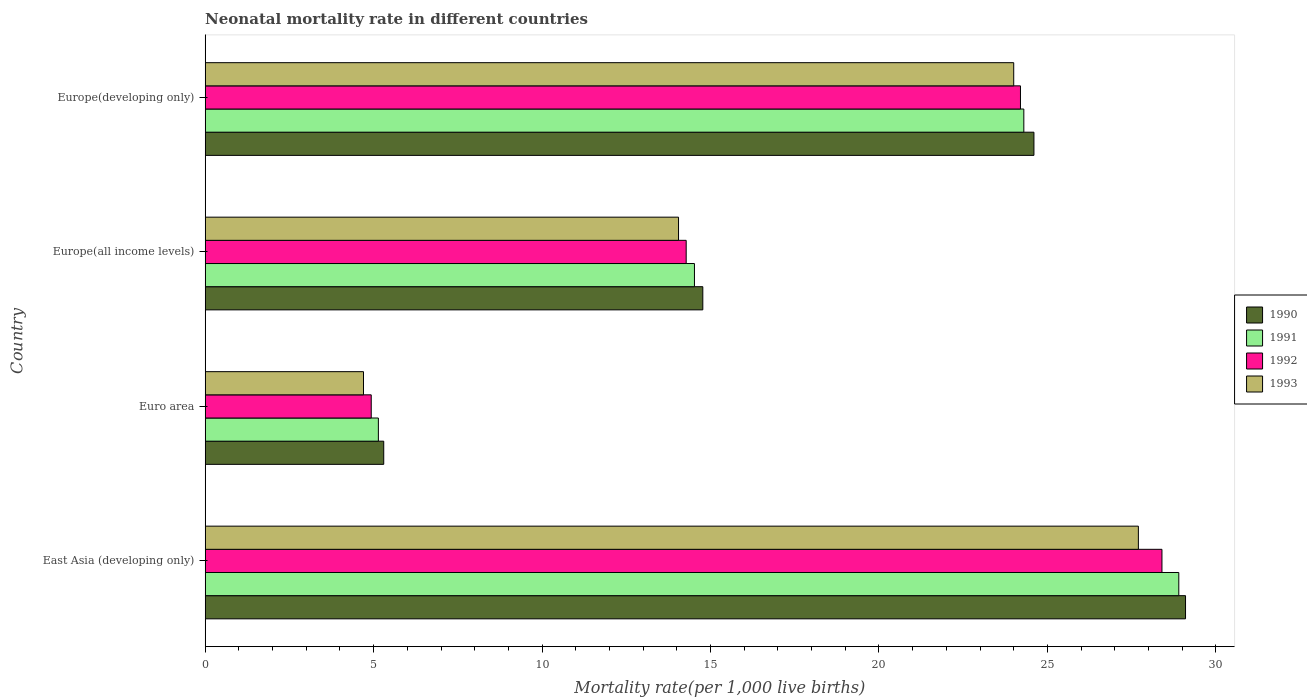How many groups of bars are there?
Your response must be concise. 4. Are the number of bars per tick equal to the number of legend labels?
Your answer should be compact. Yes. Are the number of bars on each tick of the Y-axis equal?
Ensure brevity in your answer.  Yes. How many bars are there on the 1st tick from the top?
Provide a succinct answer. 4. What is the label of the 2nd group of bars from the top?
Offer a terse response. Europe(all income levels). In how many cases, is the number of bars for a given country not equal to the number of legend labels?
Your response must be concise. 0. What is the neonatal mortality rate in 1992 in Euro area?
Your answer should be very brief. 4.93. Across all countries, what is the maximum neonatal mortality rate in 1990?
Provide a short and direct response. 29.1. Across all countries, what is the minimum neonatal mortality rate in 1990?
Offer a very short reply. 5.3. In which country was the neonatal mortality rate in 1990 maximum?
Provide a succinct answer. East Asia (developing only). What is the total neonatal mortality rate in 1992 in the graph?
Ensure brevity in your answer.  71.81. What is the difference between the neonatal mortality rate in 1993 in East Asia (developing only) and that in Europe(all income levels)?
Your response must be concise. 13.65. What is the difference between the neonatal mortality rate in 1990 in Euro area and the neonatal mortality rate in 1992 in East Asia (developing only)?
Provide a short and direct response. -23.1. What is the average neonatal mortality rate in 1993 per country?
Provide a succinct answer. 17.61. What is the difference between the neonatal mortality rate in 1990 and neonatal mortality rate in 1992 in Euro area?
Make the answer very short. 0.37. In how many countries, is the neonatal mortality rate in 1993 greater than 2 ?
Your answer should be very brief. 4. What is the ratio of the neonatal mortality rate in 1990 in Europe(all income levels) to that in Europe(developing only)?
Offer a very short reply. 0.6. Is the difference between the neonatal mortality rate in 1990 in East Asia (developing only) and Europe(all income levels) greater than the difference between the neonatal mortality rate in 1992 in East Asia (developing only) and Europe(all income levels)?
Provide a short and direct response. Yes. What is the difference between the highest and the second highest neonatal mortality rate in 1990?
Your response must be concise. 4.5. What is the difference between the highest and the lowest neonatal mortality rate in 1993?
Give a very brief answer. 23. Is the sum of the neonatal mortality rate in 1990 in East Asia (developing only) and Europe(all income levels) greater than the maximum neonatal mortality rate in 1992 across all countries?
Offer a very short reply. Yes. Is it the case that in every country, the sum of the neonatal mortality rate in 1993 and neonatal mortality rate in 1992 is greater than the sum of neonatal mortality rate in 1990 and neonatal mortality rate in 1991?
Ensure brevity in your answer.  No. What does the 2nd bar from the top in East Asia (developing only) represents?
Make the answer very short. 1992. What does the 2nd bar from the bottom in Europe(all income levels) represents?
Give a very brief answer. 1991. Is it the case that in every country, the sum of the neonatal mortality rate in 1991 and neonatal mortality rate in 1993 is greater than the neonatal mortality rate in 1992?
Your answer should be compact. Yes. How many countries are there in the graph?
Ensure brevity in your answer.  4. What is the difference between two consecutive major ticks on the X-axis?
Offer a terse response. 5. Does the graph contain any zero values?
Ensure brevity in your answer.  No. Where does the legend appear in the graph?
Offer a very short reply. Center right. How many legend labels are there?
Your answer should be compact. 4. How are the legend labels stacked?
Offer a very short reply. Vertical. What is the title of the graph?
Offer a terse response. Neonatal mortality rate in different countries. What is the label or title of the X-axis?
Provide a succinct answer. Mortality rate(per 1,0 live births). What is the label or title of the Y-axis?
Ensure brevity in your answer.  Country. What is the Mortality rate(per 1,000 live births) of 1990 in East Asia (developing only)?
Provide a succinct answer. 29.1. What is the Mortality rate(per 1,000 live births) in 1991 in East Asia (developing only)?
Provide a short and direct response. 28.9. What is the Mortality rate(per 1,000 live births) in 1992 in East Asia (developing only)?
Ensure brevity in your answer.  28.4. What is the Mortality rate(per 1,000 live births) of 1993 in East Asia (developing only)?
Your response must be concise. 27.7. What is the Mortality rate(per 1,000 live births) of 1990 in Euro area?
Make the answer very short. 5.3. What is the Mortality rate(per 1,000 live births) of 1991 in Euro area?
Your answer should be very brief. 5.14. What is the Mortality rate(per 1,000 live births) of 1992 in Euro area?
Keep it short and to the point. 4.93. What is the Mortality rate(per 1,000 live births) of 1993 in Euro area?
Make the answer very short. 4.7. What is the Mortality rate(per 1,000 live births) in 1990 in Europe(all income levels)?
Give a very brief answer. 14.77. What is the Mortality rate(per 1,000 live births) of 1991 in Europe(all income levels)?
Provide a short and direct response. 14.52. What is the Mortality rate(per 1,000 live births) of 1992 in Europe(all income levels)?
Provide a succinct answer. 14.28. What is the Mortality rate(per 1,000 live births) of 1993 in Europe(all income levels)?
Give a very brief answer. 14.05. What is the Mortality rate(per 1,000 live births) of 1990 in Europe(developing only)?
Ensure brevity in your answer.  24.6. What is the Mortality rate(per 1,000 live births) of 1991 in Europe(developing only)?
Offer a terse response. 24.3. What is the Mortality rate(per 1,000 live births) in 1992 in Europe(developing only)?
Provide a short and direct response. 24.2. Across all countries, what is the maximum Mortality rate(per 1,000 live births) of 1990?
Your answer should be very brief. 29.1. Across all countries, what is the maximum Mortality rate(per 1,000 live births) of 1991?
Keep it short and to the point. 28.9. Across all countries, what is the maximum Mortality rate(per 1,000 live births) of 1992?
Your answer should be very brief. 28.4. Across all countries, what is the maximum Mortality rate(per 1,000 live births) in 1993?
Offer a very short reply. 27.7. Across all countries, what is the minimum Mortality rate(per 1,000 live births) of 1990?
Keep it short and to the point. 5.3. Across all countries, what is the minimum Mortality rate(per 1,000 live births) of 1991?
Ensure brevity in your answer.  5.14. Across all countries, what is the minimum Mortality rate(per 1,000 live births) in 1992?
Provide a succinct answer. 4.93. Across all countries, what is the minimum Mortality rate(per 1,000 live births) in 1993?
Your answer should be very brief. 4.7. What is the total Mortality rate(per 1,000 live births) in 1990 in the graph?
Keep it short and to the point. 73.77. What is the total Mortality rate(per 1,000 live births) of 1991 in the graph?
Provide a succinct answer. 72.86. What is the total Mortality rate(per 1,000 live births) in 1992 in the graph?
Your response must be concise. 71.81. What is the total Mortality rate(per 1,000 live births) in 1993 in the graph?
Your answer should be very brief. 70.45. What is the difference between the Mortality rate(per 1,000 live births) in 1990 in East Asia (developing only) and that in Euro area?
Provide a succinct answer. 23.8. What is the difference between the Mortality rate(per 1,000 live births) in 1991 in East Asia (developing only) and that in Euro area?
Make the answer very short. 23.76. What is the difference between the Mortality rate(per 1,000 live births) in 1992 in East Asia (developing only) and that in Euro area?
Keep it short and to the point. 23.47. What is the difference between the Mortality rate(per 1,000 live births) of 1993 in East Asia (developing only) and that in Euro area?
Your answer should be compact. 23. What is the difference between the Mortality rate(per 1,000 live births) of 1990 in East Asia (developing only) and that in Europe(all income levels)?
Offer a terse response. 14.33. What is the difference between the Mortality rate(per 1,000 live births) of 1991 in East Asia (developing only) and that in Europe(all income levels)?
Your answer should be compact. 14.38. What is the difference between the Mortality rate(per 1,000 live births) in 1992 in East Asia (developing only) and that in Europe(all income levels)?
Your answer should be compact. 14.12. What is the difference between the Mortality rate(per 1,000 live births) of 1993 in East Asia (developing only) and that in Europe(all income levels)?
Your response must be concise. 13.65. What is the difference between the Mortality rate(per 1,000 live births) in 1992 in East Asia (developing only) and that in Europe(developing only)?
Your response must be concise. 4.2. What is the difference between the Mortality rate(per 1,000 live births) in 1990 in Euro area and that in Europe(all income levels)?
Your response must be concise. -9.47. What is the difference between the Mortality rate(per 1,000 live births) of 1991 in Euro area and that in Europe(all income levels)?
Give a very brief answer. -9.38. What is the difference between the Mortality rate(per 1,000 live births) in 1992 in Euro area and that in Europe(all income levels)?
Ensure brevity in your answer.  -9.35. What is the difference between the Mortality rate(per 1,000 live births) of 1993 in Euro area and that in Europe(all income levels)?
Your answer should be very brief. -9.35. What is the difference between the Mortality rate(per 1,000 live births) in 1990 in Euro area and that in Europe(developing only)?
Your response must be concise. -19.3. What is the difference between the Mortality rate(per 1,000 live births) in 1991 in Euro area and that in Europe(developing only)?
Provide a short and direct response. -19.16. What is the difference between the Mortality rate(per 1,000 live births) of 1992 in Euro area and that in Europe(developing only)?
Make the answer very short. -19.27. What is the difference between the Mortality rate(per 1,000 live births) of 1993 in Euro area and that in Europe(developing only)?
Your answer should be very brief. -19.3. What is the difference between the Mortality rate(per 1,000 live births) in 1990 in Europe(all income levels) and that in Europe(developing only)?
Your response must be concise. -9.83. What is the difference between the Mortality rate(per 1,000 live births) in 1991 in Europe(all income levels) and that in Europe(developing only)?
Keep it short and to the point. -9.78. What is the difference between the Mortality rate(per 1,000 live births) in 1992 in Europe(all income levels) and that in Europe(developing only)?
Make the answer very short. -9.92. What is the difference between the Mortality rate(per 1,000 live births) in 1993 in Europe(all income levels) and that in Europe(developing only)?
Provide a succinct answer. -9.95. What is the difference between the Mortality rate(per 1,000 live births) of 1990 in East Asia (developing only) and the Mortality rate(per 1,000 live births) of 1991 in Euro area?
Keep it short and to the point. 23.96. What is the difference between the Mortality rate(per 1,000 live births) of 1990 in East Asia (developing only) and the Mortality rate(per 1,000 live births) of 1992 in Euro area?
Offer a very short reply. 24.17. What is the difference between the Mortality rate(per 1,000 live births) of 1990 in East Asia (developing only) and the Mortality rate(per 1,000 live births) of 1993 in Euro area?
Offer a terse response. 24.4. What is the difference between the Mortality rate(per 1,000 live births) of 1991 in East Asia (developing only) and the Mortality rate(per 1,000 live births) of 1992 in Euro area?
Your response must be concise. 23.97. What is the difference between the Mortality rate(per 1,000 live births) in 1991 in East Asia (developing only) and the Mortality rate(per 1,000 live births) in 1993 in Euro area?
Your answer should be very brief. 24.2. What is the difference between the Mortality rate(per 1,000 live births) in 1992 in East Asia (developing only) and the Mortality rate(per 1,000 live births) in 1993 in Euro area?
Your response must be concise. 23.7. What is the difference between the Mortality rate(per 1,000 live births) in 1990 in East Asia (developing only) and the Mortality rate(per 1,000 live births) in 1991 in Europe(all income levels)?
Your answer should be very brief. 14.58. What is the difference between the Mortality rate(per 1,000 live births) of 1990 in East Asia (developing only) and the Mortality rate(per 1,000 live births) of 1992 in Europe(all income levels)?
Give a very brief answer. 14.82. What is the difference between the Mortality rate(per 1,000 live births) of 1990 in East Asia (developing only) and the Mortality rate(per 1,000 live births) of 1993 in Europe(all income levels)?
Your response must be concise. 15.05. What is the difference between the Mortality rate(per 1,000 live births) in 1991 in East Asia (developing only) and the Mortality rate(per 1,000 live births) in 1992 in Europe(all income levels)?
Your answer should be very brief. 14.62. What is the difference between the Mortality rate(per 1,000 live births) in 1991 in East Asia (developing only) and the Mortality rate(per 1,000 live births) in 1993 in Europe(all income levels)?
Provide a succinct answer. 14.85. What is the difference between the Mortality rate(per 1,000 live births) of 1992 in East Asia (developing only) and the Mortality rate(per 1,000 live births) of 1993 in Europe(all income levels)?
Give a very brief answer. 14.35. What is the difference between the Mortality rate(per 1,000 live births) of 1990 in East Asia (developing only) and the Mortality rate(per 1,000 live births) of 1991 in Europe(developing only)?
Make the answer very short. 4.8. What is the difference between the Mortality rate(per 1,000 live births) of 1990 in East Asia (developing only) and the Mortality rate(per 1,000 live births) of 1993 in Europe(developing only)?
Provide a short and direct response. 5.1. What is the difference between the Mortality rate(per 1,000 live births) of 1991 in East Asia (developing only) and the Mortality rate(per 1,000 live births) of 1993 in Europe(developing only)?
Provide a succinct answer. 4.9. What is the difference between the Mortality rate(per 1,000 live births) in 1990 in Euro area and the Mortality rate(per 1,000 live births) in 1991 in Europe(all income levels)?
Ensure brevity in your answer.  -9.22. What is the difference between the Mortality rate(per 1,000 live births) in 1990 in Euro area and the Mortality rate(per 1,000 live births) in 1992 in Europe(all income levels)?
Provide a short and direct response. -8.98. What is the difference between the Mortality rate(per 1,000 live births) of 1990 in Euro area and the Mortality rate(per 1,000 live births) of 1993 in Europe(all income levels)?
Provide a short and direct response. -8.75. What is the difference between the Mortality rate(per 1,000 live births) in 1991 in Euro area and the Mortality rate(per 1,000 live births) in 1992 in Europe(all income levels)?
Give a very brief answer. -9.14. What is the difference between the Mortality rate(per 1,000 live births) of 1991 in Euro area and the Mortality rate(per 1,000 live births) of 1993 in Europe(all income levels)?
Give a very brief answer. -8.91. What is the difference between the Mortality rate(per 1,000 live births) in 1992 in Euro area and the Mortality rate(per 1,000 live births) in 1993 in Europe(all income levels)?
Offer a terse response. -9.12. What is the difference between the Mortality rate(per 1,000 live births) in 1990 in Euro area and the Mortality rate(per 1,000 live births) in 1991 in Europe(developing only)?
Make the answer very short. -19. What is the difference between the Mortality rate(per 1,000 live births) in 1990 in Euro area and the Mortality rate(per 1,000 live births) in 1992 in Europe(developing only)?
Provide a short and direct response. -18.9. What is the difference between the Mortality rate(per 1,000 live births) of 1990 in Euro area and the Mortality rate(per 1,000 live births) of 1993 in Europe(developing only)?
Provide a succinct answer. -18.7. What is the difference between the Mortality rate(per 1,000 live births) in 1991 in Euro area and the Mortality rate(per 1,000 live births) in 1992 in Europe(developing only)?
Offer a very short reply. -19.06. What is the difference between the Mortality rate(per 1,000 live births) in 1991 in Euro area and the Mortality rate(per 1,000 live births) in 1993 in Europe(developing only)?
Offer a very short reply. -18.86. What is the difference between the Mortality rate(per 1,000 live births) of 1992 in Euro area and the Mortality rate(per 1,000 live births) of 1993 in Europe(developing only)?
Your answer should be compact. -19.07. What is the difference between the Mortality rate(per 1,000 live births) of 1990 in Europe(all income levels) and the Mortality rate(per 1,000 live births) of 1991 in Europe(developing only)?
Your answer should be very brief. -9.53. What is the difference between the Mortality rate(per 1,000 live births) of 1990 in Europe(all income levels) and the Mortality rate(per 1,000 live births) of 1992 in Europe(developing only)?
Your answer should be compact. -9.43. What is the difference between the Mortality rate(per 1,000 live births) in 1990 in Europe(all income levels) and the Mortality rate(per 1,000 live births) in 1993 in Europe(developing only)?
Provide a succinct answer. -9.23. What is the difference between the Mortality rate(per 1,000 live births) in 1991 in Europe(all income levels) and the Mortality rate(per 1,000 live births) in 1992 in Europe(developing only)?
Your answer should be compact. -9.68. What is the difference between the Mortality rate(per 1,000 live births) in 1991 in Europe(all income levels) and the Mortality rate(per 1,000 live births) in 1993 in Europe(developing only)?
Your answer should be compact. -9.48. What is the difference between the Mortality rate(per 1,000 live births) of 1992 in Europe(all income levels) and the Mortality rate(per 1,000 live births) of 1993 in Europe(developing only)?
Give a very brief answer. -9.72. What is the average Mortality rate(per 1,000 live births) in 1990 per country?
Give a very brief answer. 18.44. What is the average Mortality rate(per 1,000 live births) of 1991 per country?
Your answer should be very brief. 18.22. What is the average Mortality rate(per 1,000 live births) in 1992 per country?
Ensure brevity in your answer.  17.95. What is the average Mortality rate(per 1,000 live births) of 1993 per country?
Provide a short and direct response. 17.61. What is the difference between the Mortality rate(per 1,000 live births) in 1990 and Mortality rate(per 1,000 live births) in 1991 in East Asia (developing only)?
Provide a short and direct response. 0.2. What is the difference between the Mortality rate(per 1,000 live births) in 1990 and Mortality rate(per 1,000 live births) in 1992 in East Asia (developing only)?
Your response must be concise. 0.7. What is the difference between the Mortality rate(per 1,000 live births) of 1990 and Mortality rate(per 1,000 live births) of 1993 in East Asia (developing only)?
Provide a succinct answer. 1.4. What is the difference between the Mortality rate(per 1,000 live births) of 1990 and Mortality rate(per 1,000 live births) of 1991 in Euro area?
Provide a succinct answer. 0.16. What is the difference between the Mortality rate(per 1,000 live births) of 1990 and Mortality rate(per 1,000 live births) of 1992 in Euro area?
Your response must be concise. 0.37. What is the difference between the Mortality rate(per 1,000 live births) of 1990 and Mortality rate(per 1,000 live births) of 1993 in Euro area?
Keep it short and to the point. 0.6. What is the difference between the Mortality rate(per 1,000 live births) of 1991 and Mortality rate(per 1,000 live births) of 1992 in Euro area?
Give a very brief answer. 0.21. What is the difference between the Mortality rate(per 1,000 live births) of 1991 and Mortality rate(per 1,000 live births) of 1993 in Euro area?
Give a very brief answer. 0.44. What is the difference between the Mortality rate(per 1,000 live births) of 1992 and Mortality rate(per 1,000 live births) of 1993 in Euro area?
Give a very brief answer. 0.23. What is the difference between the Mortality rate(per 1,000 live births) in 1990 and Mortality rate(per 1,000 live births) in 1991 in Europe(all income levels)?
Offer a terse response. 0.25. What is the difference between the Mortality rate(per 1,000 live births) of 1990 and Mortality rate(per 1,000 live births) of 1992 in Europe(all income levels)?
Provide a short and direct response. 0.49. What is the difference between the Mortality rate(per 1,000 live births) of 1990 and Mortality rate(per 1,000 live births) of 1993 in Europe(all income levels)?
Provide a succinct answer. 0.72. What is the difference between the Mortality rate(per 1,000 live births) in 1991 and Mortality rate(per 1,000 live births) in 1992 in Europe(all income levels)?
Offer a very short reply. 0.25. What is the difference between the Mortality rate(per 1,000 live births) in 1991 and Mortality rate(per 1,000 live births) in 1993 in Europe(all income levels)?
Provide a short and direct response. 0.47. What is the difference between the Mortality rate(per 1,000 live births) in 1992 and Mortality rate(per 1,000 live births) in 1993 in Europe(all income levels)?
Your answer should be compact. 0.23. What is the difference between the Mortality rate(per 1,000 live births) in 1990 and Mortality rate(per 1,000 live births) in 1991 in Europe(developing only)?
Keep it short and to the point. 0.3. What is the difference between the Mortality rate(per 1,000 live births) of 1990 and Mortality rate(per 1,000 live births) of 1993 in Europe(developing only)?
Provide a short and direct response. 0.6. What is the difference between the Mortality rate(per 1,000 live births) in 1992 and Mortality rate(per 1,000 live births) in 1993 in Europe(developing only)?
Keep it short and to the point. 0.2. What is the ratio of the Mortality rate(per 1,000 live births) in 1990 in East Asia (developing only) to that in Euro area?
Your response must be concise. 5.49. What is the ratio of the Mortality rate(per 1,000 live births) of 1991 in East Asia (developing only) to that in Euro area?
Make the answer very short. 5.62. What is the ratio of the Mortality rate(per 1,000 live births) of 1992 in East Asia (developing only) to that in Euro area?
Keep it short and to the point. 5.76. What is the ratio of the Mortality rate(per 1,000 live births) of 1993 in East Asia (developing only) to that in Euro area?
Ensure brevity in your answer.  5.89. What is the ratio of the Mortality rate(per 1,000 live births) of 1990 in East Asia (developing only) to that in Europe(all income levels)?
Offer a terse response. 1.97. What is the ratio of the Mortality rate(per 1,000 live births) of 1991 in East Asia (developing only) to that in Europe(all income levels)?
Ensure brevity in your answer.  1.99. What is the ratio of the Mortality rate(per 1,000 live births) of 1992 in East Asia (developing only) to that in Europe(all income levels)?
Your response must be concise. 1.99. What is the ratio of the Mortality rate(per 1,000 live births) of 1993 in East Asia (developing only) to that in Europe(all income levels)?
Ensure brevity in your answer.  1.97. What is the ratio of the Mortality rate(per 1,000 live births) of 1990 in East Asia (developing only) to that in Europe(developing only)?
Your answer should be compact. 1.18. What is the ratio of the Mortality rate(per 1,000 live births) in 1991 in East Asia (developing only) to that in Europe(developing only)?
Give a very brief answer. 1.19. What is the ratio of the Mortality rate(per 1,000 live births) in 1992 in East Asia (developing only) to that in Europe(developing only)?
Your response must be concise. 1.17. What is the ratio of the Mortality rate(per 1,000 live births) in 1993 in East Asia (developing only) to that in Europe(developing only)?
Ensure brevity in your answer.  1.15. What is the ratio of the Mortality rate(per 1,000 live births) in 1990 in Euro area to that in Europe(all income levels)?
Make the answer very short. 0.36. What is the ratio of the Mortality rate(per 1,000 live births) of 1991 in Euro area to that in Europe(all income levels)?
Give a very brief answer. 0.35. What is the ratio of the Mortality rate(per 1,000 live births) in 1992 in Euro area to that in Europe(all income levels)?
Ensure brevity in your answer.  0.35. What is the ratio of the Mortality rate(per 1,000 live births) in 1993 in Euro area to that in Europe(all income levels)?
Offer a terse response. 0.33. What is the ratio of the Mortality rate(per 1,000 live births) in 1990 in Euro area to that in Europe(developing only)?
Your answer should be compact. 0.22. What is the ratio of the Mortality rate(per 1,000 live births) in 1991 in Euro area to that in Europe(developing only)?
Give a very brief answer. 0.21. What is the ratio of the Mortality rate(per 1,000 live births) of 1992 in Euro area to that in Europe(developing only)?
Give a very brief answer. 0.2. What is the ratio of the Mortality rate(per 1,000 live births) in 1993 in Euro area to that in Europe(developing only)?
Give a very brief answer. 0.2. What is the ratio of the Mortality rate(per 1,000 live births) in 1990 in Europe(all income levels) to that in Europe(developing only)?
Your answer should be compact. 0.6. What is the ratio of the Mortality rate(per 1,000 live births) of 1991 in Europe(all income levels) to that in Europe(developing only)?
Provide a short and direct response. 0.6. What is the ratio of the Mortality rate(per 1,000 live births) of 1992 in Europe(all income levels) to that in Europe(developing only)?
Make the answer very short. 0.59. What is the ratio of the Mortality rate(per 1,000 live births) of 1993 in Europe(all income levels) to that in Europe(developing only)?
Your response must be concise. 0.59. What is the difference between the highest and the second highest Mortality rate(per 1,000 live births) of 1990?
Ensure brevity in your answer.  4.5. What is the difference between the highest and the second highest Mortality rate(per 1,000 live births) in 1991?
Keep it short and to the point. 4.6. What is the difference between the highest and the second highest Mortality rate(per 1,000 live births) in 1992?
Keep it short and to the point. 4.2. What is the difference between the highest and the second highest Mortality rate(per 1,000 live births) in 1993?
Give a very brief answer. 3.7. What is the difference between the highest and the lowest Mortality rate(per 1,000 live births) of 1990?
Ensure brevity in your answer.  23.8. What is the difference between the highest and the lowest Mortality rate(per 1,000 live births) of 1991?
Make the answer very short. 23.76. What is the difference between the highest and the lowest Mortality rate(per 1,000 live births) in 1992?
Offer a very short reply. 23.47. What is the difference between the highest and the lowest Mortality rate(per 1,000 live births) in 1993?
Offer a terse response. 23. 